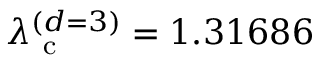Convert formula to latex. <formula><loc_0><loc_0><loc_500><loc_500>\lambda _ { c } ^ { ( d = 3 ) } = 1 . 3 1 6 8 6</formula> 